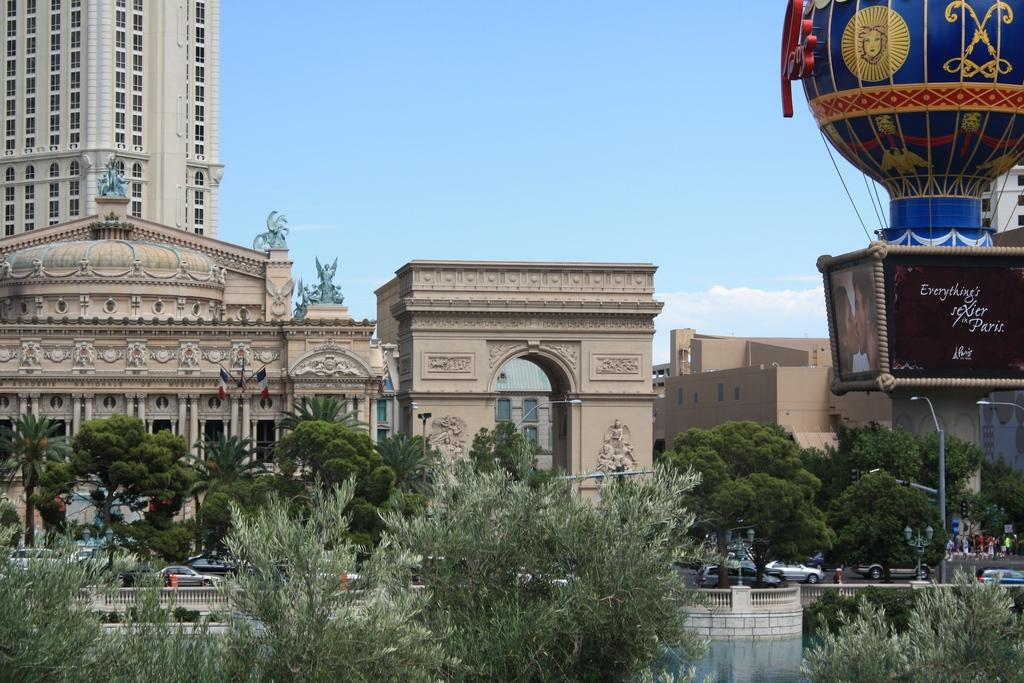What is the main structure in the center of the image? There is an arch in the center of the image. What can be seen on the left side of the image? There are buildings on the left side of the image. What types of objects are present at the bottom of the image? Trees, poles, and cars are present at the bottom of the image. What type of barrier is visible in the image? There is a fence in the image. What is visible at the top of the image? The sky is visible at the top of the image. What type of insurance policy is being discussed in the image? There is no discussion or insurance policy present in the image; it features an arch, buildings, trees, poles, cars, a fence, and the sky. What type of beam is holding up the arch in the image? The image does not show any beams supporting the arch; it only shows the arch itself. 